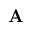<formula> <loc_0><loc_0><loc_500><loc_500>{ A }</formula> 